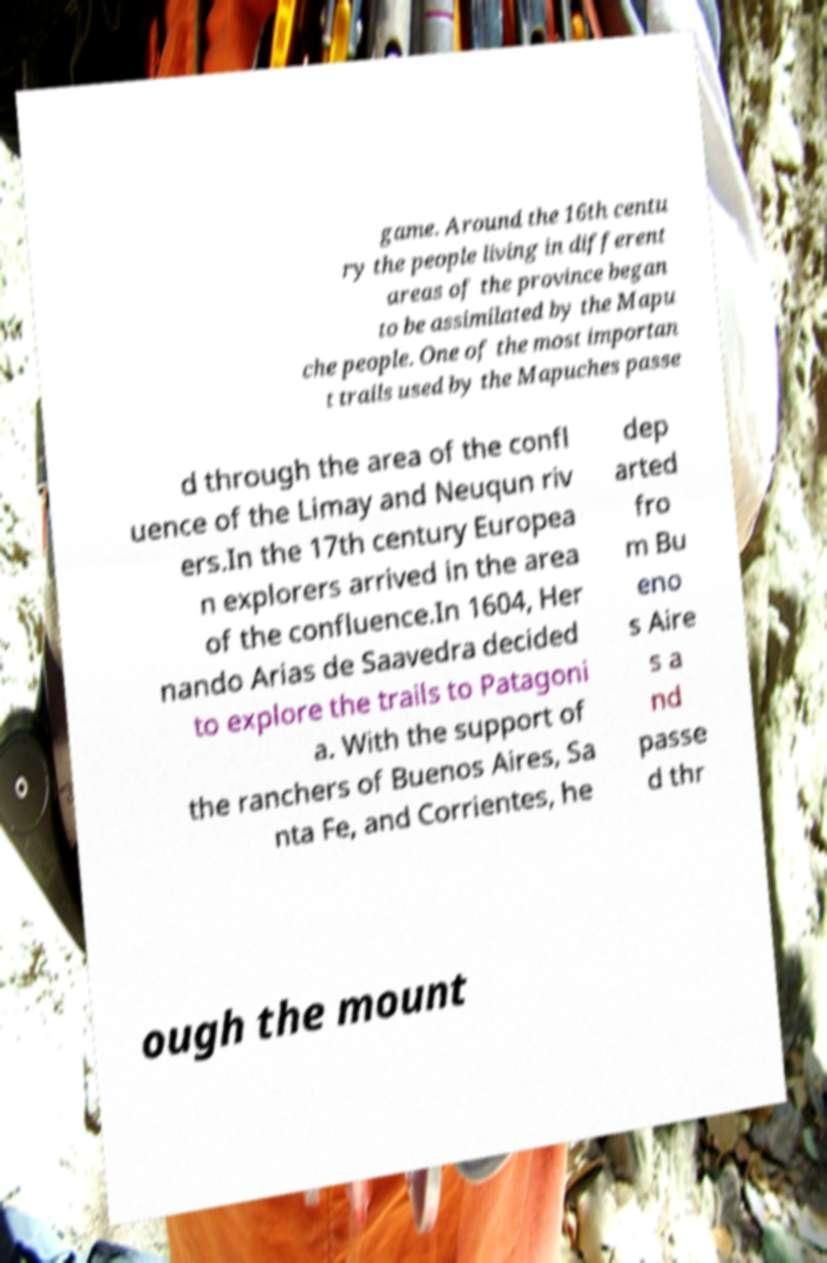Please identify and transcribe the text found in this image. game. Around the 16th centu ry the people living in different areas of the province began to be assimilated by the Mapu che people. One of the most importan t trails used by the Mapuches passe d through the area of the confl uence of the Limay and Neuqun riv ers.In the 17th century Europea n explorers arrived in the area of the confluence.In 1604, Her nando Arias de Saavedra decided to explore the trails to Patagoni a. With the support of the ranchers of Buenos Aires, Sa nta Fe, and Corrientes, he dep arted fro m Bu eno s Aire s a nd passe d thr ough the mount 